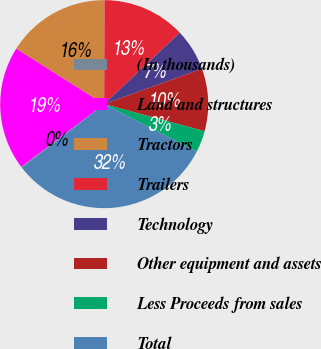<chart> <loc_0><loc_0><loc_500><loc_500><pie_chart><fcel>(In thousands)<fcel>Land and structures<fcel>Tractors<fcel>Trailers<fcel>Technology<fcel>Other equipment and assets<fcel>Less Proceeds from sales<fcel>Total<nl><fcel>0.16%<fcel>19.27%<fcel>16.08%<fcel>12.9%<fcel>6.53%<fcel>9.71%<fcel>3.34%<fcel>32.01%<nl></chart> 